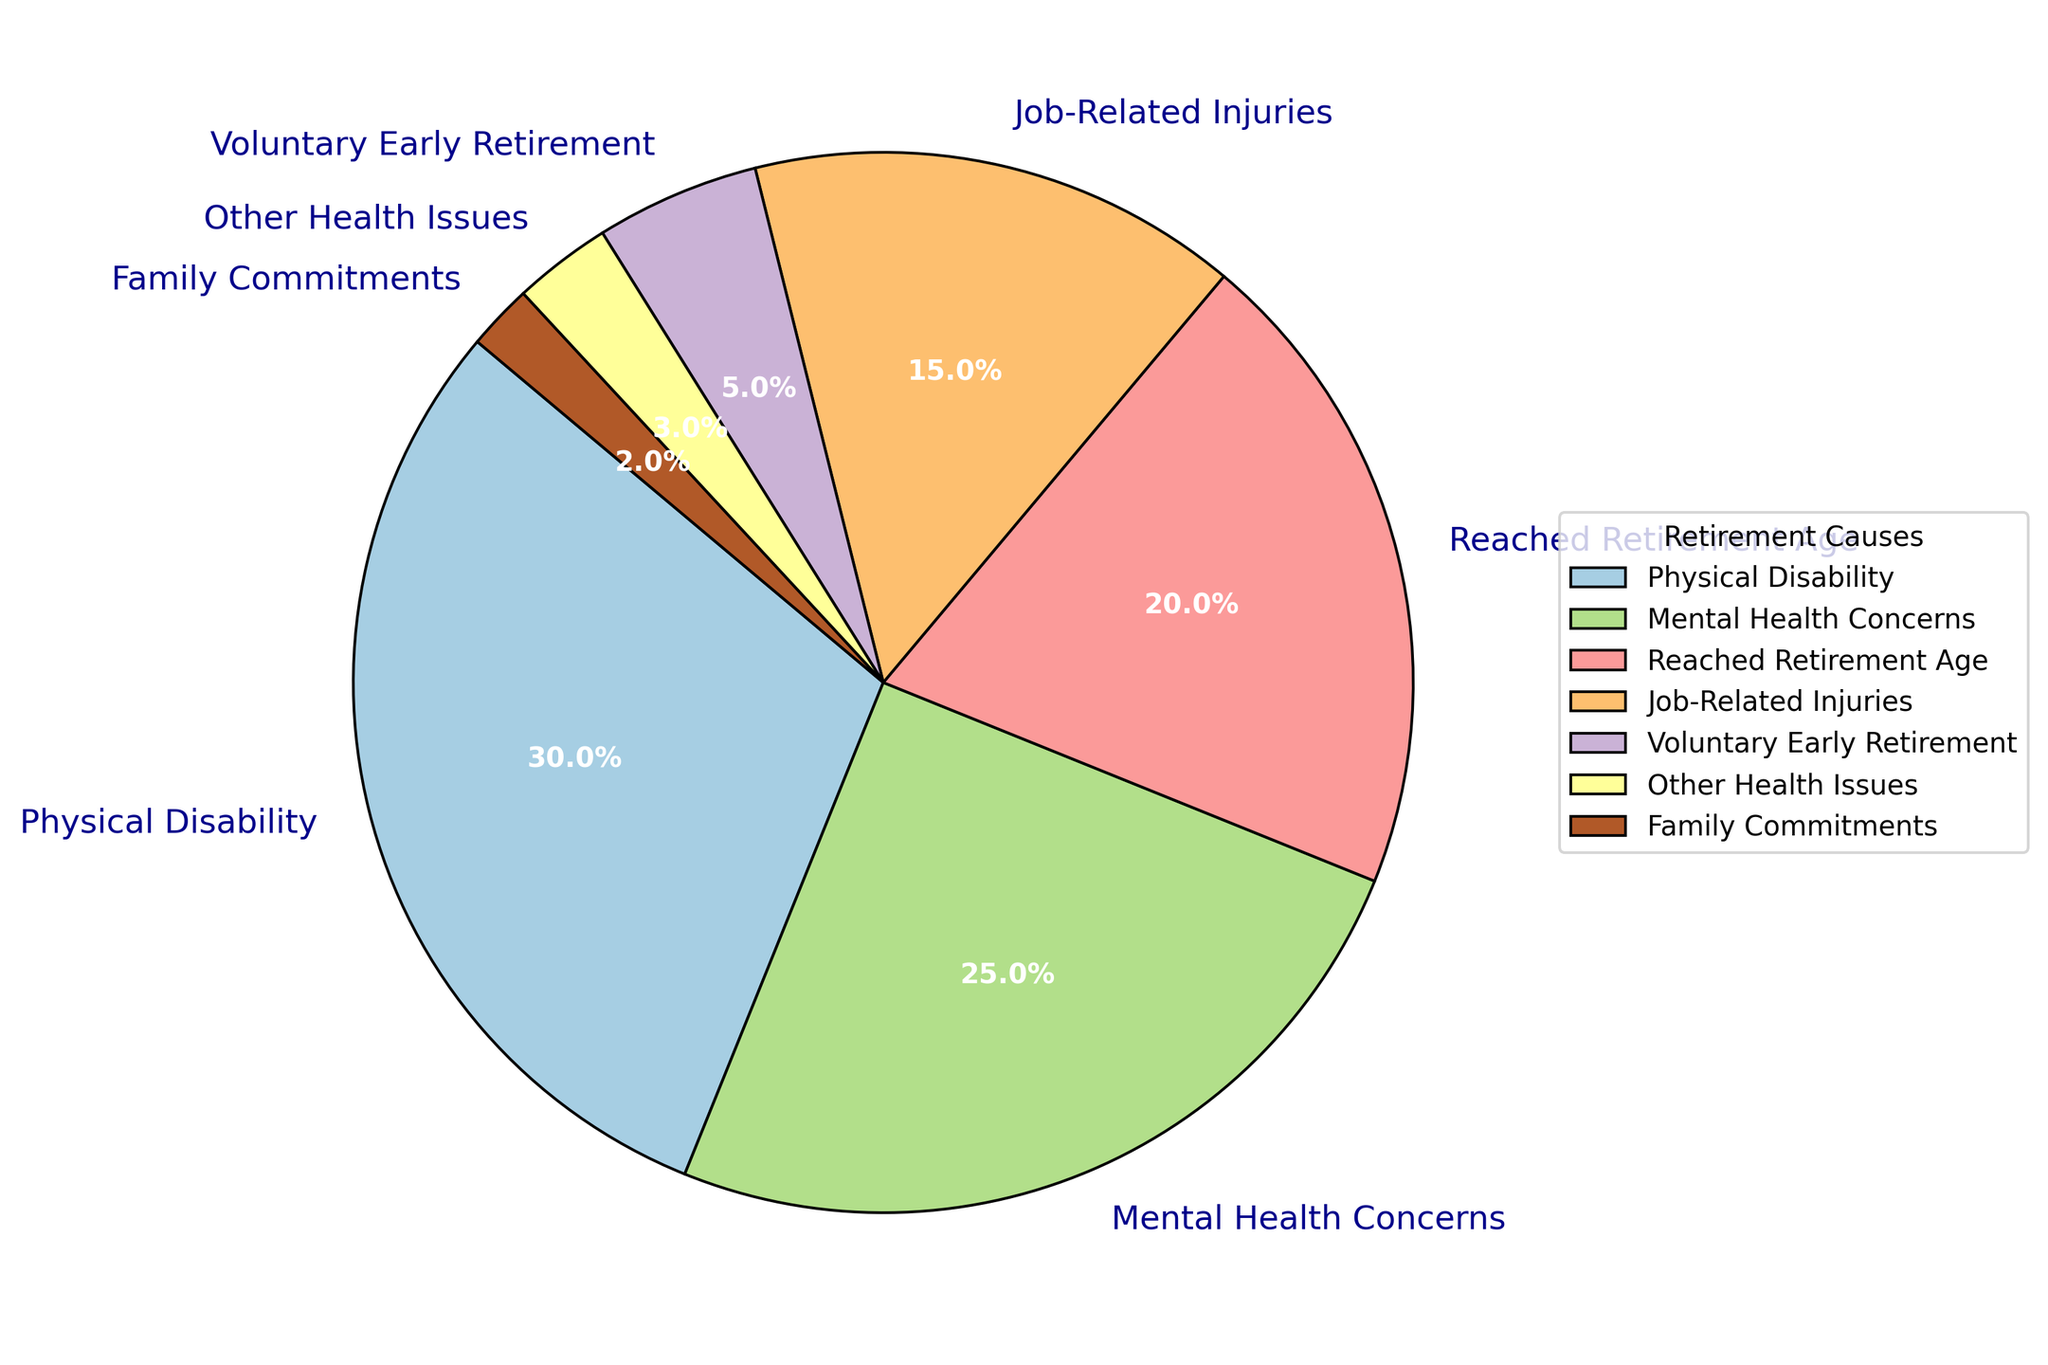What's the largest cause for retirement among police officers? To find the largest cause for retirement, look for the sector with the highest percentage share in the pie chart. "Physical Disability" holds the largest share with 30%.
Answer: Physical Disability Which retirement cause has a 25% share? Identify the sector of the pie chart labeled with 25%. This sector is marked as "Mental Health Concerns."
Answer: Mental Health Concerns How much greater is the percentage of Physical Disability causes compared to Job-Related Injuries? Locate the percentages for both "Physical Disability" (30%) and "Job-Related Injuries" (15%). Subtract the smaller percentage from the larger one: 30% - 15% = 15%.
Answer: 15% Which causes have less than a 5% share? Look for sectors smaller than 5% in the chart. These are "Other Health Issues" (3%) and "Family Commitments" (2%).
Answer: Other Health Issues, Family Commitments What is the combined percentage of Mental Health Concerns and Voluntary Early Retirement? Add the percentages of "Mental Health Concerns" (25%) and "Voluntary Early Retirement" (5%): 25% + 5% = 30%.
Answer: 30% Which color in the pie chart represents reached retirement age? Identify the label "Reached Retirement Age" and see its corresponding color in the chart. (Note: This depends on the colors used in the actual chart.)
Answer: (Color associated with Reached Retirement Age sector) Which causes for retirement have exactly double the percentage of Family Commitments? Family Commitments has 2%, so double this is 4%. Examine the chart for any sectors with 4%. Since there are no exact matches, Family Commitments alone does not have a double-share counterpart.
Answer: None What is the relative percentage difference between Mental Health Concerns and Reached Retirement Age? Calculate the relative percentage difference using the formula ((higher percentage - lower percentage) / lower percentage) * 100. For "Mental Health Concerns" (25%) and "Reached Retirement Age" (20%): ((25% - 20%) / 20%) * 100 = 25%.
Answer: 25% If we grouped all health-related causes (Physical Disability, Mental Health Concerns, Job-Related Injuries, Other Health Issues), what would be their combined percentage? Sum the percentages of health-related causes: 30% (Physical Disability) + 25% (Mental Health Concerns) + 15% (Job-Related Injuries) + 3% (Other Health Issues) = 73%.
Answer: 73% 